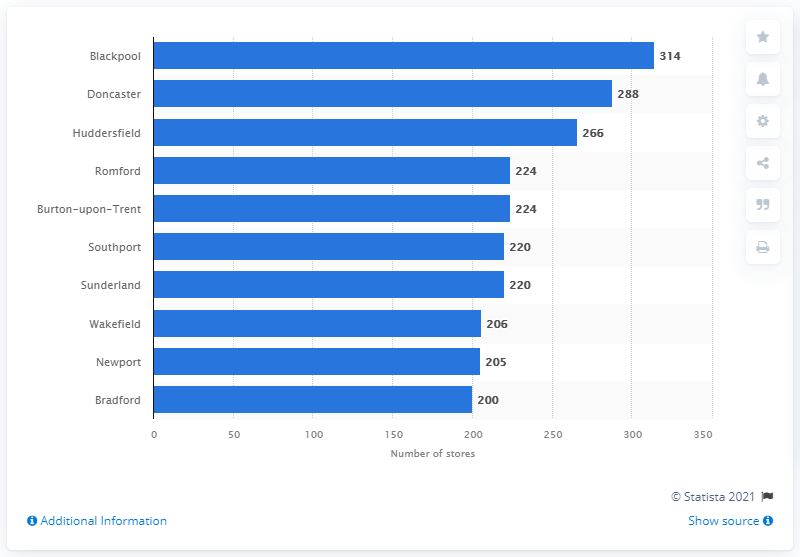List a handful of essential elements in this visual. There were 314 value retail stores located in the city of Blackpool. 